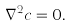Convert formula to latex. <formula><loc_0><loc_0><loc_500><loc_500>\nabla ^ { 2 } c = 0 .</formula> 